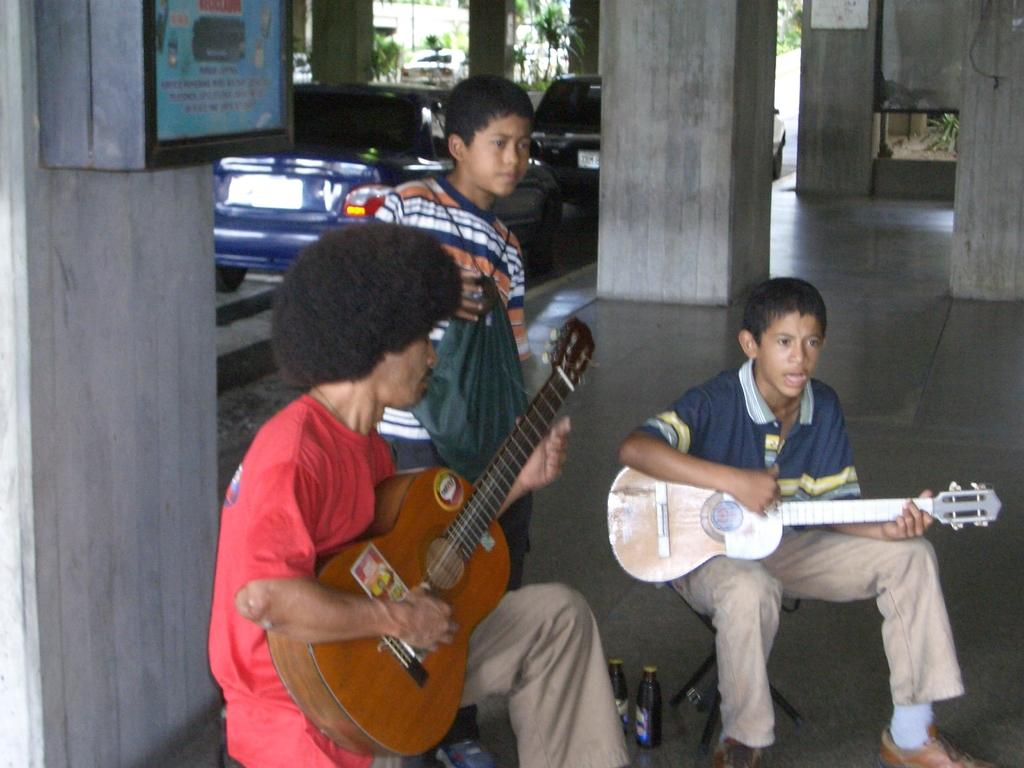What is the main subject of the image? There is a man in the image. What is the boy in the image doing? There is a boy playing guitar in the image. What is the other boy holding in the image? There is another boy holding a cover in the image. What type of vehicles can be seen in the image? Cars are visible in the image. What architectural feature is present in the image? There is a pillar in the image. What objects are present that might contain liquid? There are bottles in the image. Can you see a hook hanging from the ceiling in the image? There is no hook hanging from the ceiling in the image. Is there a house visible in the background of the image? There is no house visible in the image. 